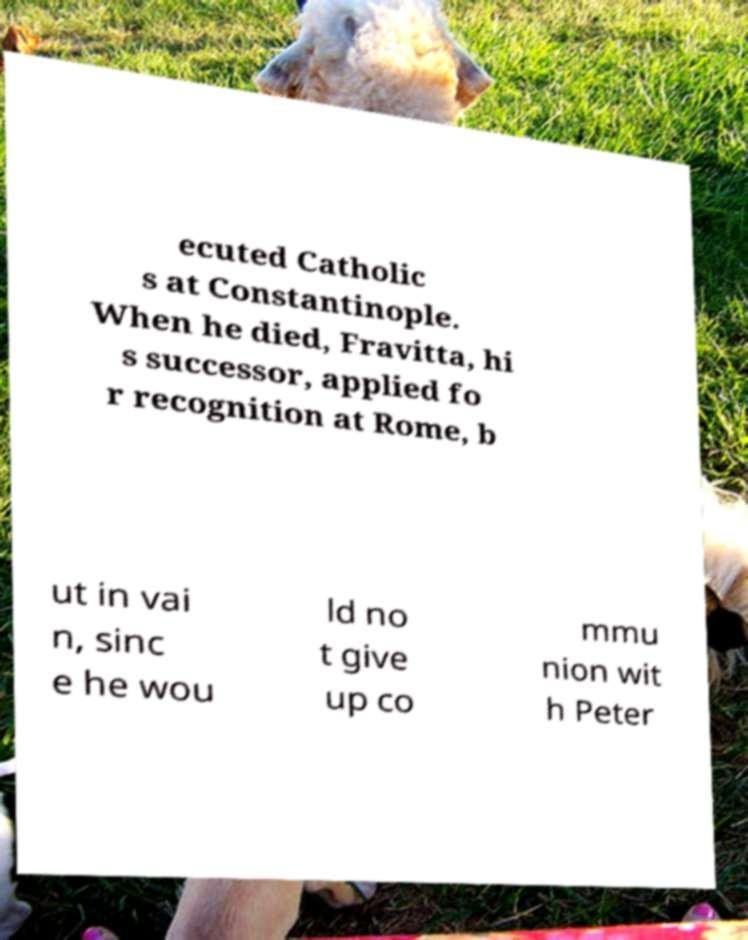I need the written content from this picture converted into text. Can you do that? ecuted Catholic s at Constantinople. When he died, Fravitta, hi s successor, applied fo r recognition at Rome, b ut in vai n, sinc e he wou ld no t give up co mmu nion wit h Peter 